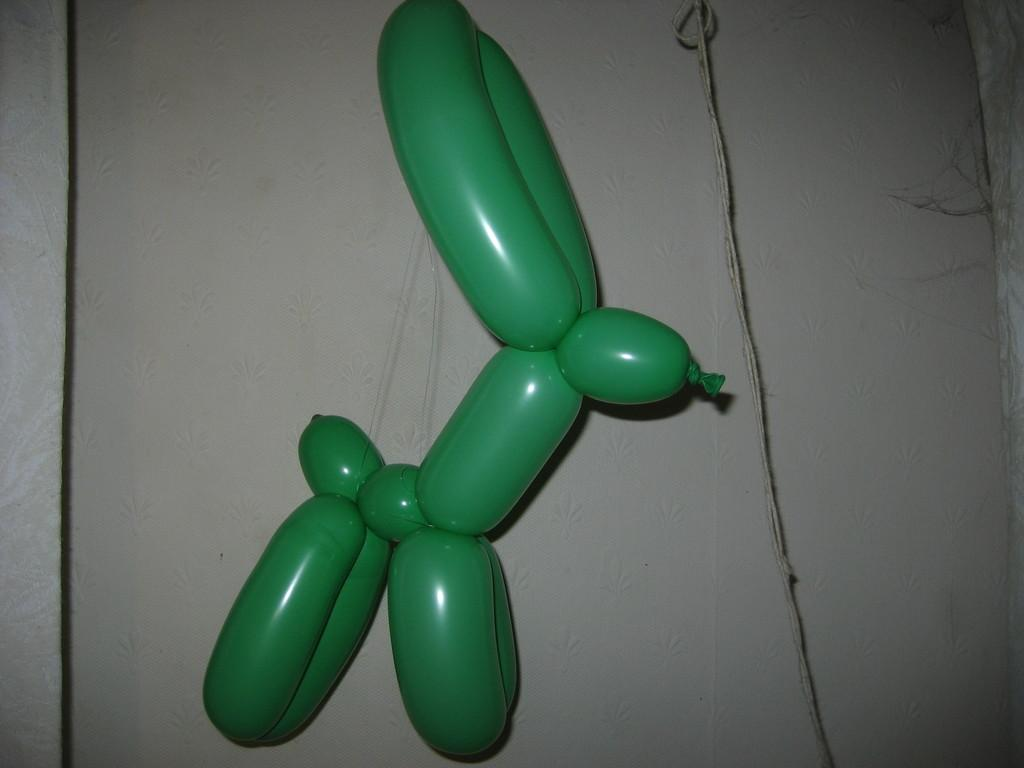What objects are present in the image? There are balloons in the image. How are the balloons arranged or connected? The balloons are tied together. Reasoning: Let' Let's think step by step in order to produce the conversation. We start by identifying the main subject in the image, which is the balloons. Then, we expand the conversation to include the specific detail about how the balloons are connected, which is by being tied together. Each question is designed to elicit a specific detail about the image that is known from the provided facts. Absurd Question/Answer: What type of metal can be seen sparking between the balloons in the image? There is no metal or spark present between the balloons in the image; they are simply tied together. 